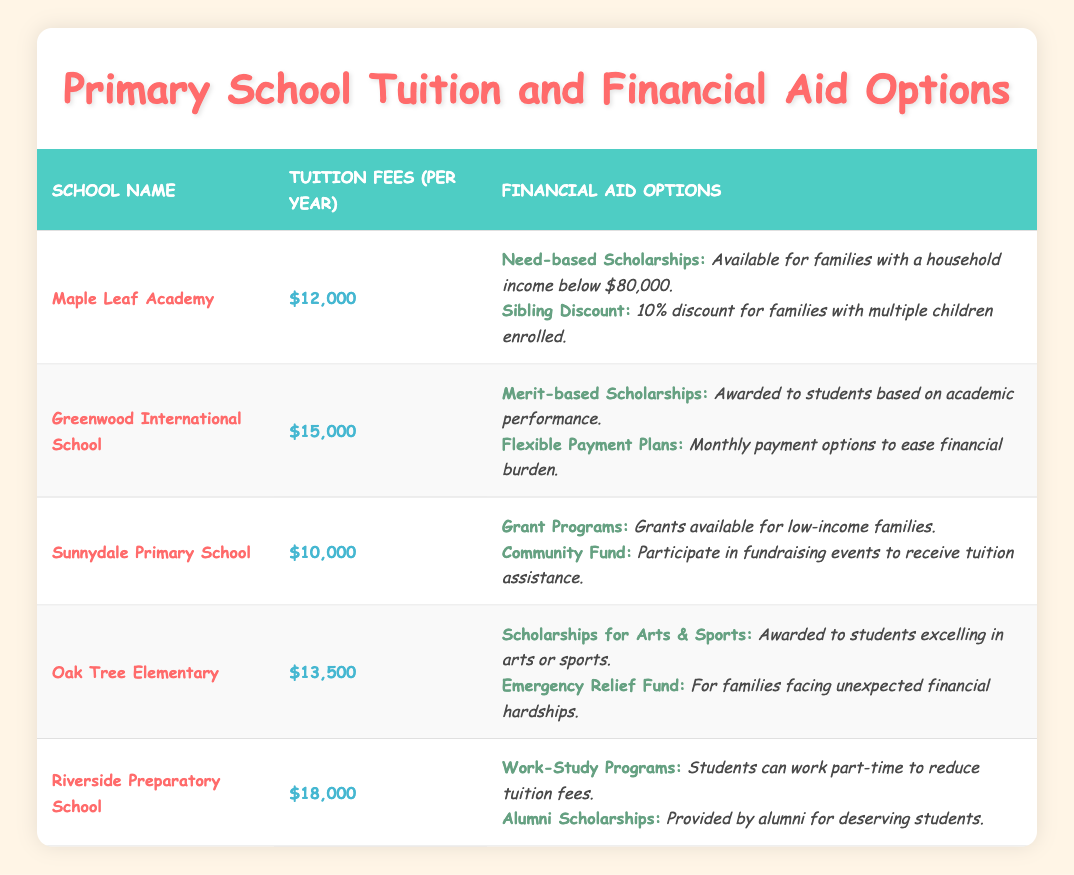What is the tuition fee for Sunnydale Primary School? Looking at the table, Sunnydale Primary School has a tuition fee listed under the "Tuition Fees" column, which shows $10,000.
Answer: $10,000 Which school offers the highest tuition fees? By scanning the "Tuition Fees" column in the table, Riverside Preparatory School shows the highest fee at $18,000.
Answer: Riverside Preparatory School Does Maple Leaf Academy provide a sibling discount option? The financial aid options for Maple Leaf Academy include a "Sibling Discount," which provides a 10% discount for families with multiple children enrolled, confirming that this option is indeed available.
Answer: Yes How much lower is the tuition fee of Sunnydale Primary School compared to Greenwood International School? Sunnydale's tuition is $10,000 and Greenwood's is $15,000. The difference is $15,000 - $10,000 = $5,000, indicating the lower fee at Sunnydale.
Answer: $5,000 Are there any financial aid options for families with household incomes below $80,000 at Maple Leaf Academy? Yes, the "Need-based Scholarships" mentioned for Maple Leaf Academy are available specifically for families with household incomes below $80,000.
Answer: Yes What is the average tuition fee of the five schools listed? To find the average, you add all the tuition fees: $12,000 + $15,000 + $10,000 + $13,500 + $18,000 = $68,500. Then, divide by the number of schools (5): $68,500 / 5 = $13,700.
Answer: $13,700 Do both Oak Tree Elementary and Riverside Preparatory School offer scholarships? Oak Tree Elementary offers "Scholarships for Arts & Sports" and Riverside Preparatory School provides "Alumni Scholarships," confirming that both schools offer scholarship options.
Answer: Yes How many schools provide financial aid options specifically for low-income families? Reviewing the financial aid options, Sunnydale Primary School offers "Grant Programs" for low-income families, and Maple Leaf Academy also has "Need-based Scholarships" for families earning below $80,000. Therefore, there are two schools with options for low-income families.
Answer: 2 Which school offers flexible payment plans among the options listed? The table indicates that Greenwood International School provides "Flexible Payment Plans" to help ease the financial burden, thus confirming that this school has that option.
Answer: Greenwood International School 